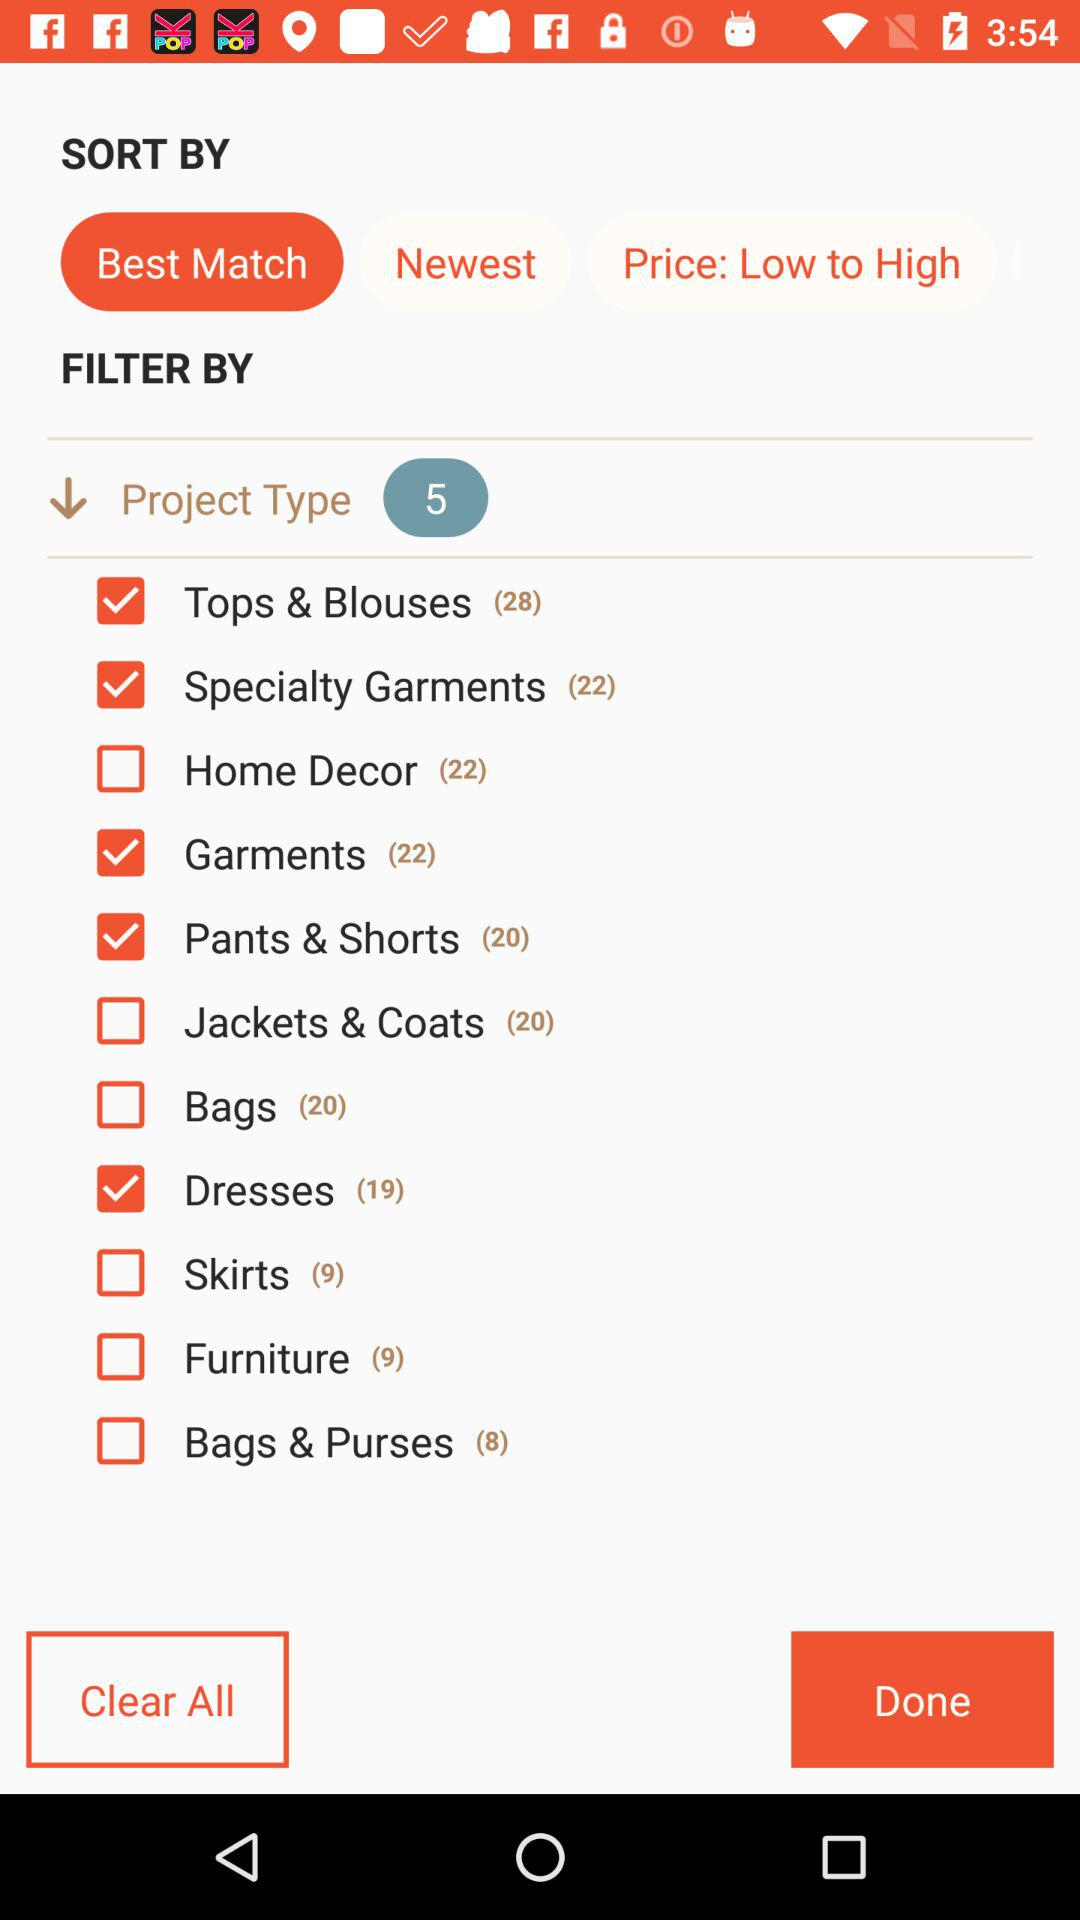What is the selected checkbox? The selected checkboxes are "Tops & Blouses", "Specialty Garments", "Garments", "Pants & Shorts" and "Dresses". 